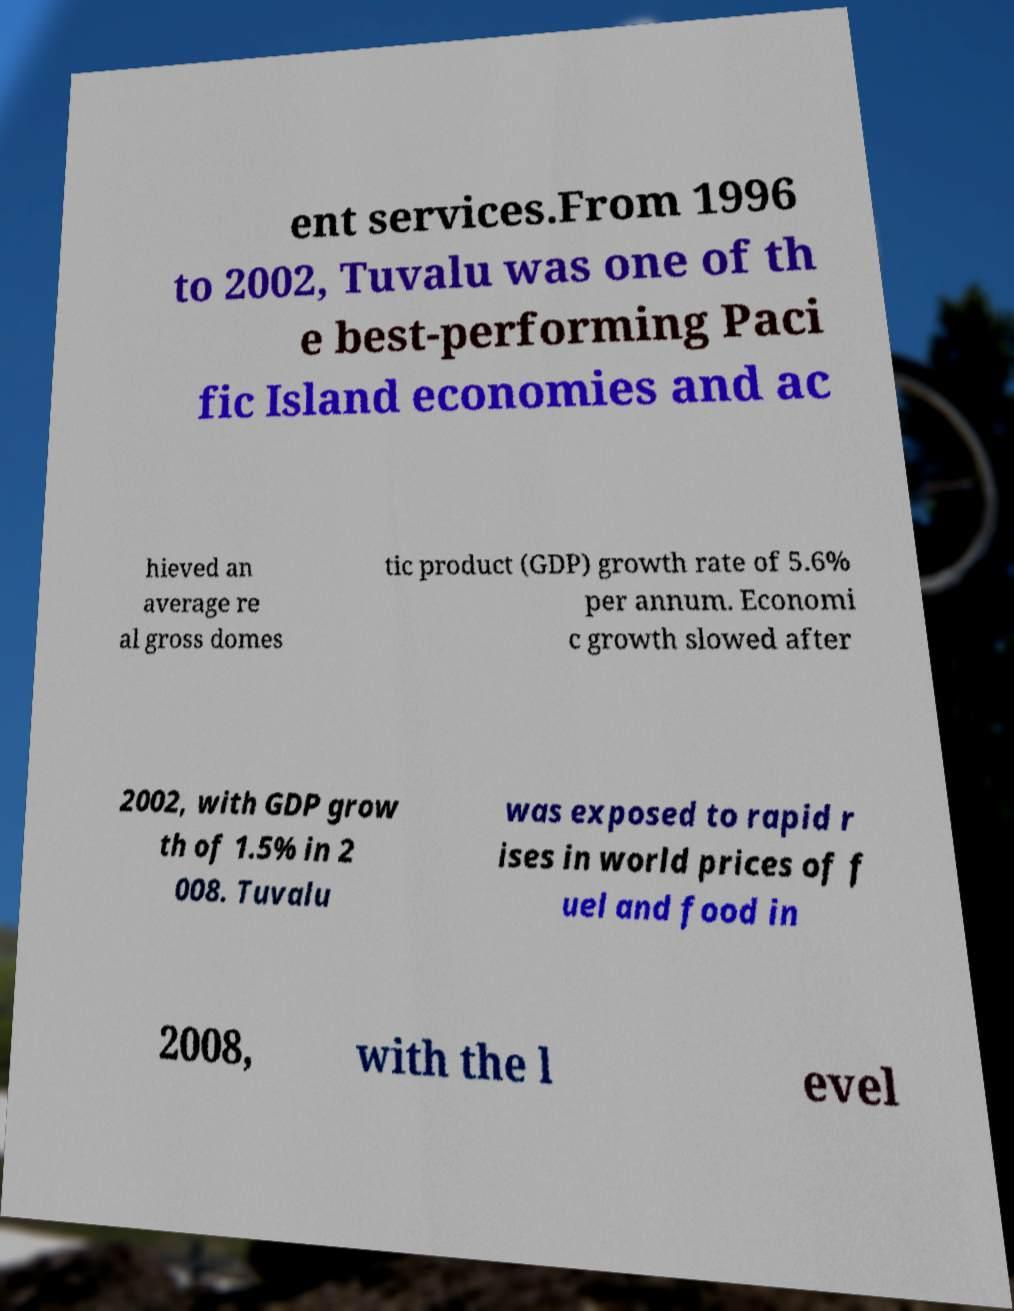What messages or text are displayed in this image? I need them in a readable, typed format. ent services.From 1996 to 2002, Tuvalu was one of th e best-performing Paci fic Island economies and ac hieved an average re al gross domes tic product (GDP) growth rate of 5.6% per annum. Economi c growth slowed after 2002, with GDP grow th of 1.5% in 2 008. Tuvalu was exposed to rapid r ises in world prices of f uel and food in 2008, with the l evel 